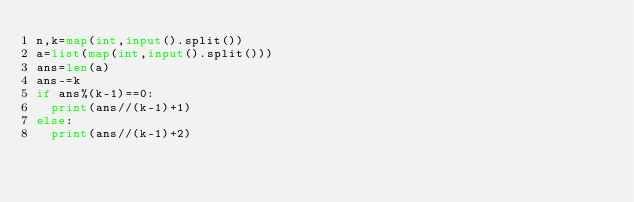<code> <loc_0><loc_0><loc_500><loc_500><_Python_>n,k=map(int,input().split())
a=list(map(int,input().split()))
ans=len(a)
ans-=k
if ans%(k-1)==0:
  print(ans//(k-1)+1)
else:
  print(ans//(k-1)+2)</code> 